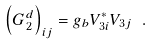Convert formula to latex. <formula><loc_0><loc_0><loc_500><loc_500>\left ( G _ { 2 } ^ { d } \right ) _ { i j } = g _ { b } V ^ { \ast } _ { 3 i } V _ { 3 j } \ .</formula> 